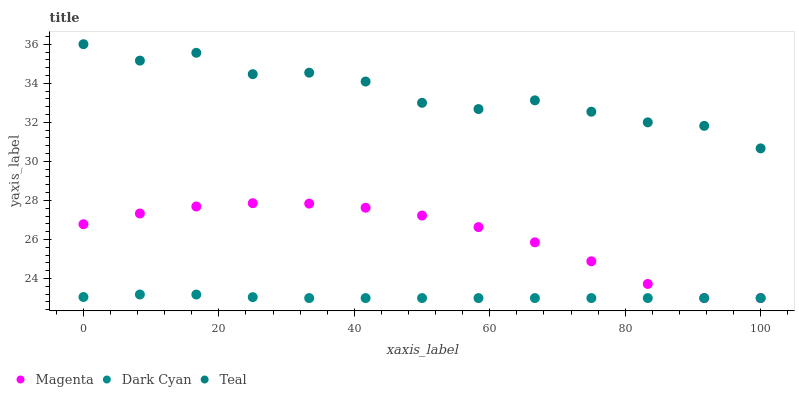Does Dark Cyan have the minimum area under the curve?
Answer yes or no. Yes. Does Teal have the maximum area under the curve?
Answer yes or no. Yes. Does Magenta have the minimum area under the curve?
Answer yes or no. No. Does Magenta have the maximum area under the curve?
Answer yes or no. No. Is Dark Cyan the smoothest?
Answer yes or no. Yes. Is Teal the roughest?
Answer yes or no. Yes. Is Magenta the smoothest?
Answer yes or no. No. Is Magenta the roughest?
Answer yes or no. No. Does Dark Cyan have the lowest value?
Answer yes or no. Yes. Does Teal have the lowest value?
Answer yes or no. No. Does Teal have the highest value?
Answer yes or no. Yes. Does Magenta have the highest value?
Answer yes or no. No. Is Dark Cyan less than Teal?
Answer yes or no. Yes. Is Teal greater than Magenta?
Answer yes or no. Yes. Does Dark Cyan intersect Magenta?
Answer yes or no. Yes. Is Dark Cyan less than Magenta?
Answer yes or no. No. Is Dark Cyan greater than Magenta?
Answer yes or no. No. Does Dark Cyan intersect Teal?
Answer yes or no. No. 